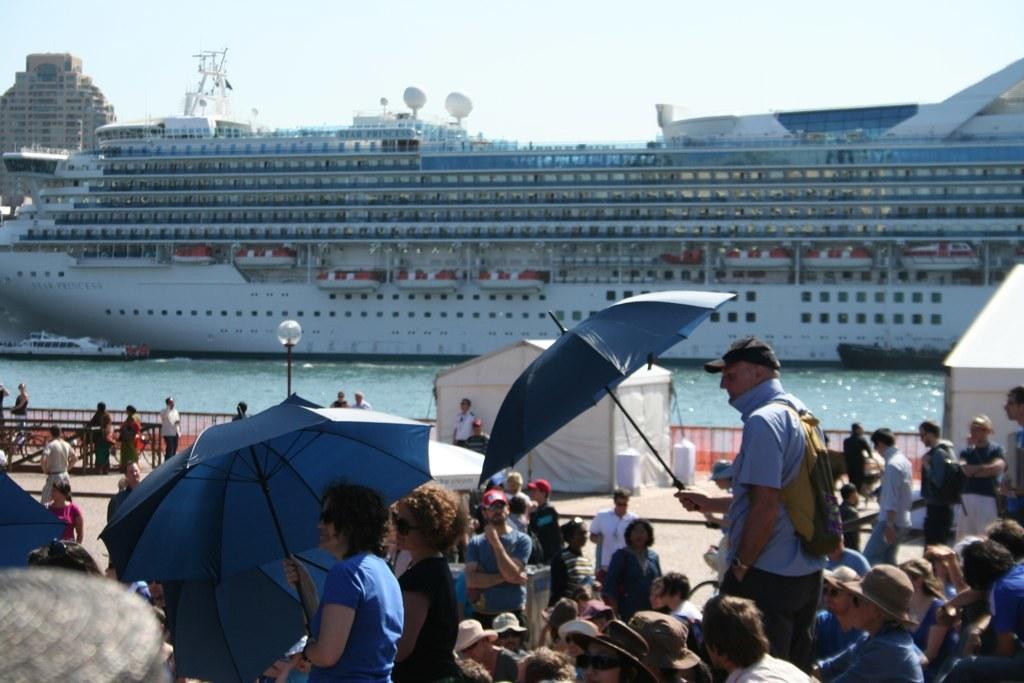Describe this image in one or two sentences. In the image we can see there are many people wearing clothes and some of them are wearing a cap. This is an umbrella, light pole, fence, tent, bicycles, water, ship and a sky. 